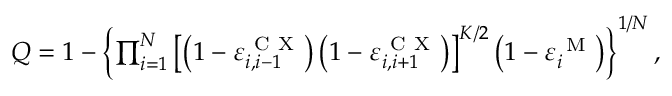Convert formula to latex. <formula><loc_0><loc_0><loc_500><loc_500>\begin{array} { r } { Q = 1 - \left \{ \prod _ { i = 1 } ^ { N } \left [ \left ( 1 - \varepsilon _ { i , i - 1 } ^ { C X } \right ) \left ( 1 - \varepsilon _ { i , i + 1 } ^ { C X } \right ) \right ] ^ { K / 2 } \left ( 1 - \varepsilon _ { i } ^ { M } \right ) \right \} ^ { 1 / { N } } , } \end{array}</formula> 